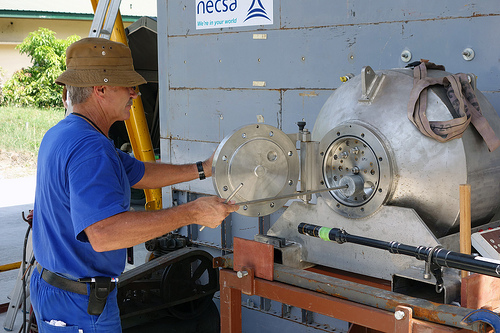<image>
Is there a person on the somthing? No. The person is not positioned on the somthing. They may be near each other, but the person is not supported by or resting on top of the somthing. 